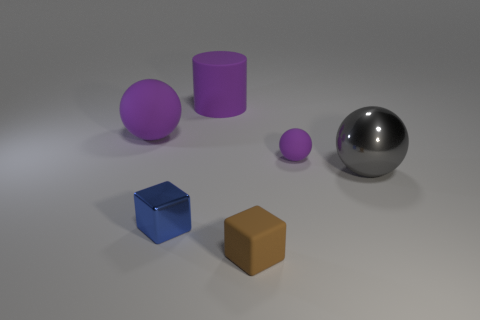Subtract all small purple balls. How many balls are left? 2 Add 1 tiny gray rubber cylinders. How many objects exist? 7 Subtract all blue blocks. How many blocks are left? 1 Subtract 1 cylinders. How many cylinders are left? 0 Subtract all cylinders. How many objects are left? 5 Add 3 tiny blue metal blocks. How many tiny blue metal blocks exist? 4 Subtract 0 cyan balls. How many objects are left? 6 Subtract all green cylinders. Subtract all yellow spheres. How many cylinders are left? 1 Subtract all cyan balls. How many yellow cylinders are left? 0 Subtract all small blue metal things. Subtract all large matte objects. How many objects are left? 3 